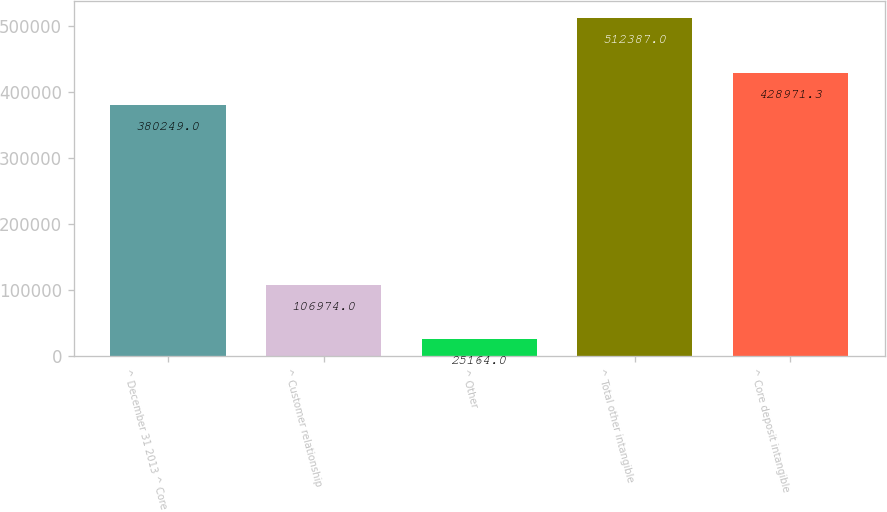Convert chart to OTSL. <chart><loc_0><loc_0><loc_500><loc_500><bar_chart><fcel>^ December 31 2013 ^ Core<fcel>^ Customer relationship<fcel>^ Other<fcel>^ Total other intangible<fcel>^ Core deposit intangible<nl><fcel>380249<fcel>106974<fcel>25164<fcel>512387<fcel>428971<nl></chart> 